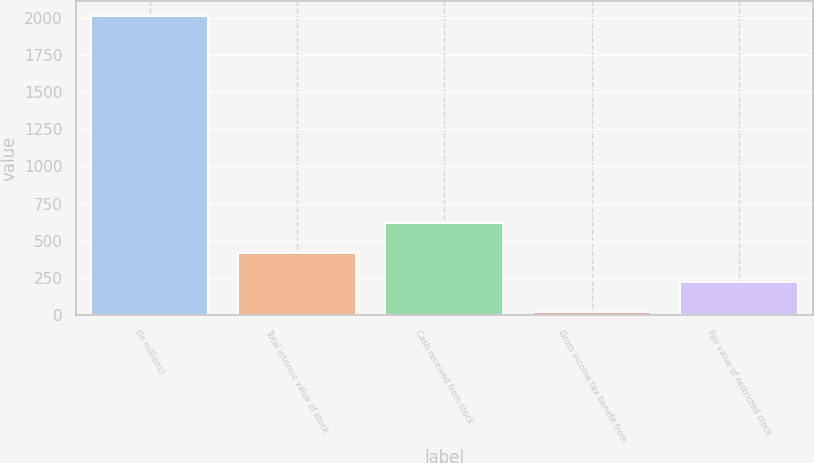<chart> <loc_0><loc_0><loc_500><loc_500><bar_chart><fcel>(In millions)<fcel>Total intrinsic value of stock<fcel>Cash received from stock<fcel>Gross income tax benefit from<fcel>Fair value of restricted stock<nl><fcel>2012<fcel>418.4<fcel>617.6<fcel>20<fcel>219.2<nl></chart> 